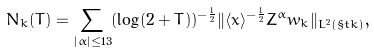<formula> <loc_0><loc_0><loc_500><loc_500>N _ { k } ( T ) = \sum _ { | \alpha | \leq 1 3 } ( \log ( 2 + T ) ) ^ { - \frac { 1 } { 2 } } \| \langle x \rangle ^ { - \frac { 1 } { 2 } } Z ^ { \alpha } w _ { k } \| _ { L ^ { 2 } ( \S t k ) } ,</formula> 